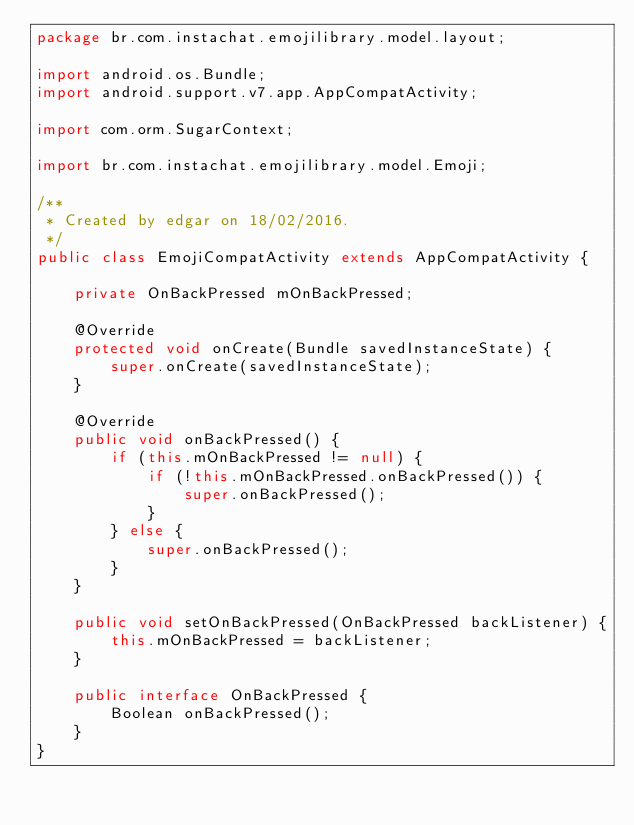<code> <loc_0><loc_0><loc_500><loc_500><_Java_>package br.com.instachat.emojilibrary.model.layout;

import android.os.Bundle;
import android.support.v7.app.AppCompatActivity;

import com.orm.SugarContext;

import br.com.instachat.emojilibrary.model.Emoji;

/**
 * Created by edgar on 18/02/2016.
 */
public class EmojiCompatActivity extends AppCompatActivity {

    private OnBackPressed mOnBackPressed;

    @Override
    protected void onCreate(Bundle savedInstanceState) {
        super.onCreate(savedInstanceState);
    }

    @Override
    public void onBackPressed() {
        if (this.mOnBackPressed != null) {
            if (!this.mOnBackPressed.onBackPressed()) {
                super.onBackPressed();
            }
        } else {
            super.onBackPressed();
        }
    }

    public void setOnBackPressed(OnBackPressed backListener) {
        this.mOnBackPressed = backListener;
    }

    public interface OnBackPressed {
        Boolean onBackPressed();
    }
}
</code> 